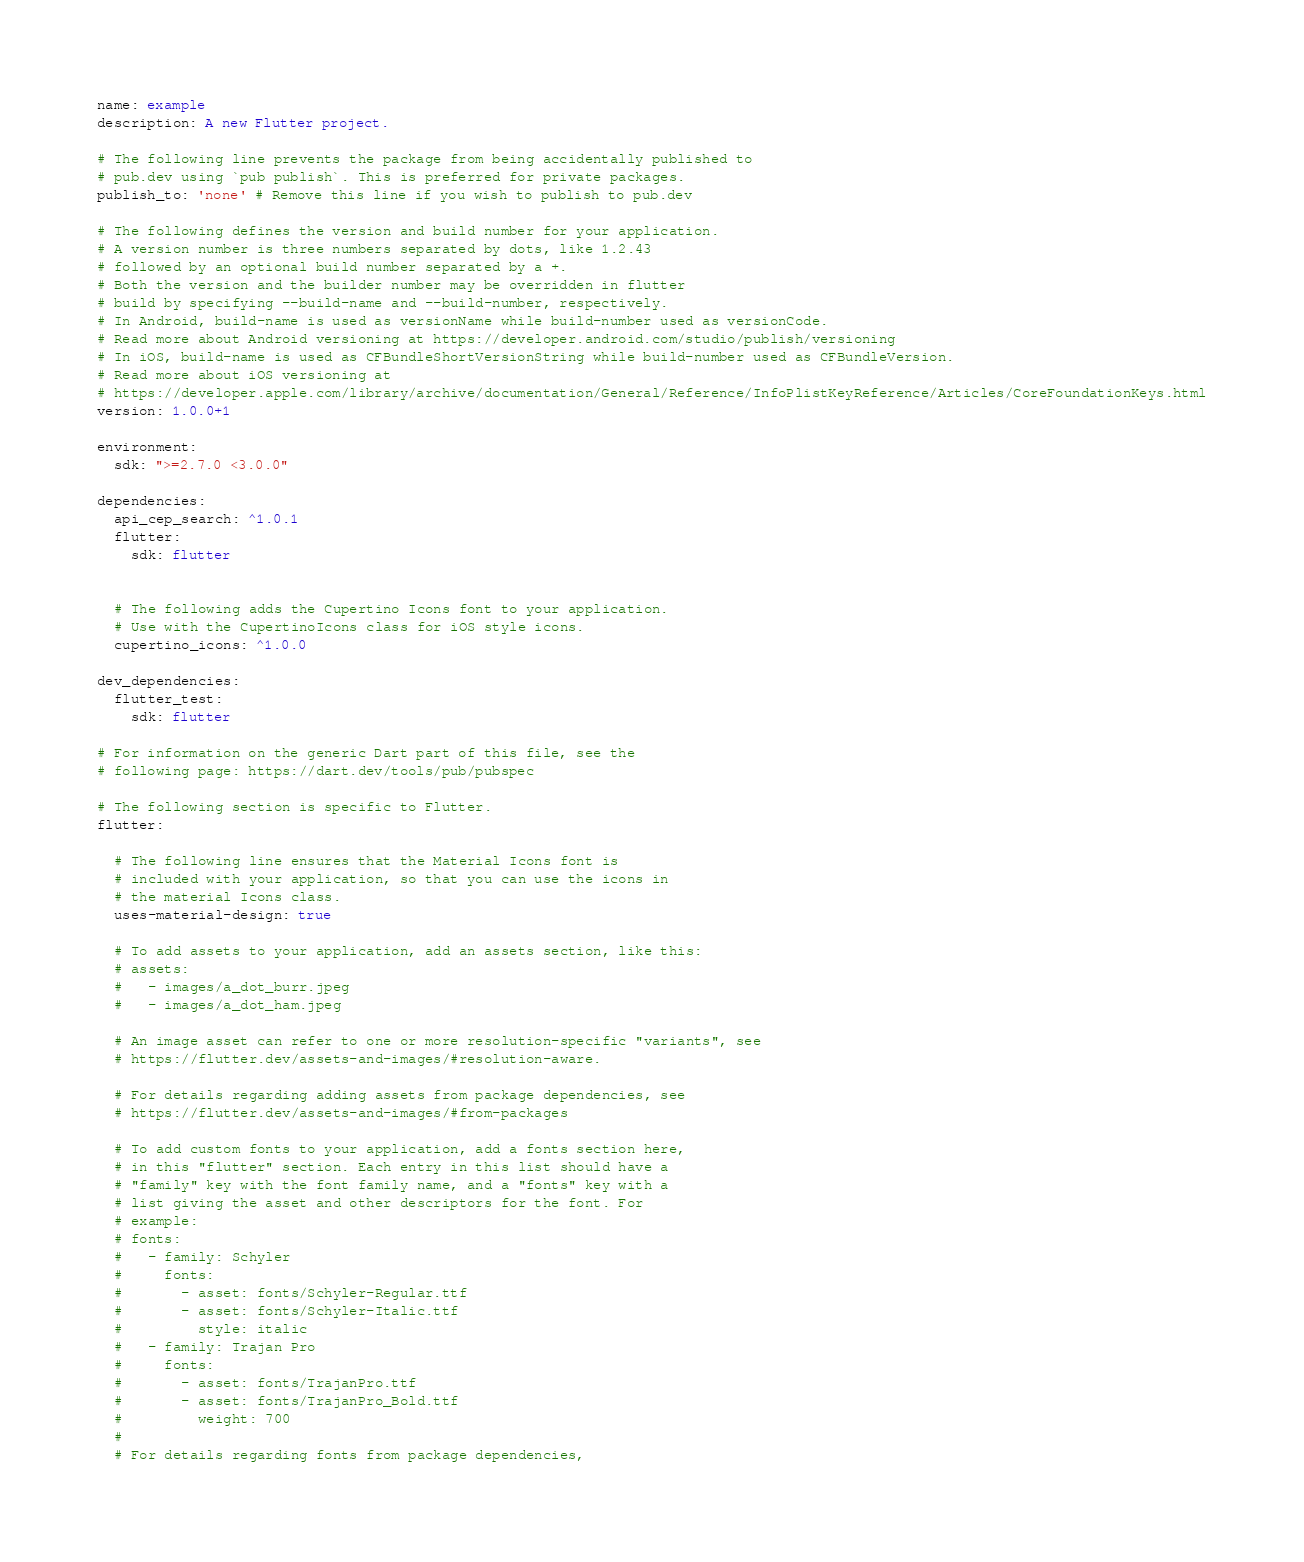Convert code to text. <code><loc_0><loc_0><loc_500><loc_500><_YAML_>name: example
description: A new Flutter project.

# The following line prevents the package from being accidentally published to
# pub.dev using `pub publish`. This is preferred for private packages.
publish_to: 'none' # Remove this line if you wish to publish to pub.dev

# The following defines the version and build number for your application.
# A version number is three numbers separated by dots, like 1.2.43
# followed by an optional build number separated by a +.
# Both the version and the builder number may be overridden in flutter
# build by specifying --build-name and --build-number, respectively.
# In Android, build-name is used as versionName while build-number used as versionCode.
# Read more about Android versioning at https://developer.android.com/studio/publish/versioning
# In iOS, build-name is used as CFBundleShortVersionString while build-number used as CFBundleVersion.
# Read more about iOS versioning at
# https://developer.apple.com/library/archive/documentation/General/Reference/InfoPlistKeyReference/Articles/CoreFoundationKeys.html
version: 1.0.0+1

environment:
  sdk: ">=2.7.0 <3.0.0"

dependencies:
  api_cep_search: ^1.0.1
  flutter:
    sdk: flutter


  # The following adds the Cupertino Icons font to your application.
  # Use with the CupertinoIcons class for iOS style icons.
  cupertino_icons: ^1.0.0

dev_dependencies:
  flutter_test:
    sdk: flutter

# For information on the generic Dart part of this file, see the
# following page: https://dart.dev/tools/pub/pubspec

# The following section is specific to Flutter.
flutter:

  # The following line ensures that the Material Icons font is
  # included with your application, so that you can use the icons in
  # the material Icons class.
  uses-material-design: true

  # To add assets to your application, add an assets section, like this:
  # assets:
  #   - images/a_dot_burr.jpeg
  #   - images/a_dot_ham.jpeg

  # An image asset can refer to one or more resolution-specific "variants", see
  # https://flutter.dev/assets-and-images/#resolution-aware.

  # For details regarding adding assets from package dependencies, see
  # https://flutter.dev/assets-and-images/#from-packages

  # To add custom fonts to your application, add a fonts section here,
  # in this "flutter" section. Each entry in this list should have a
  # "family" key with the font family name, and a "fonts" key with a
  # list giving the asset and other descriptors for the font. For
  # example:
  # fonts:
  #   - family: Schyler
  #     fonts:
  #       - asset: fonts/Schyler-Regular.ttf
  #       - asset: fonts/Schyler-Italic.ttf
  #         style: italic
  #   - family: Trajan Pro
  #     fonts:
  #       - asset: fonts/TrajanPro.ttf
  #       - asset: fonts/TrajanPro_Bold.ttf
  #         weight: 700
  #
  # For details regarding fonts from package dependencies,</code> 